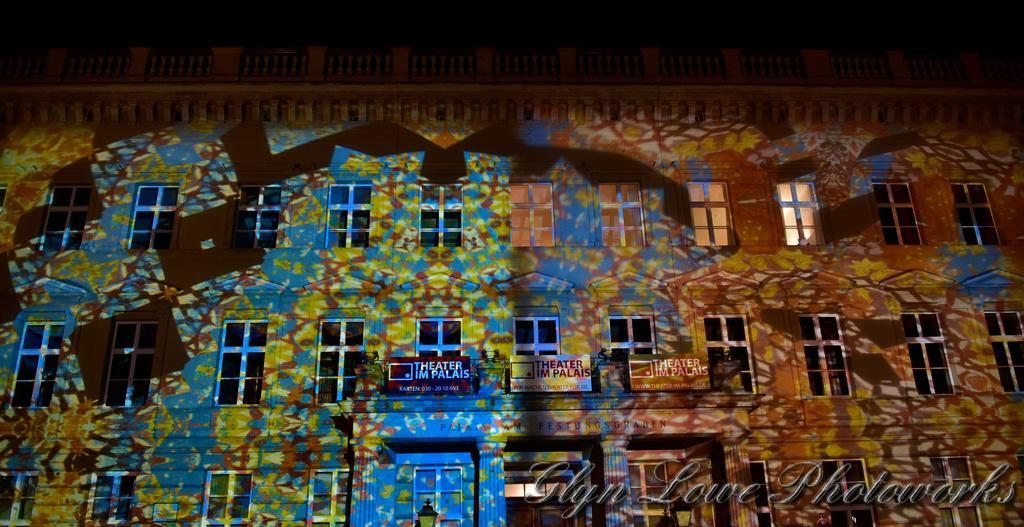What is present on the wall in the image? The wall has lights on it. Can you describe the lighting in the image? The lights on the wall provide illumination in the image. What part of the image appears to be darker? There is a dark part of the image. Is there any text or marking at the bottom right side of the image? Yes, there is a watermark at the bottom right side of the image. What type of bead is used to create the summer comfort in the image? There is no bead, summer, or comfort present in the image; it only features a wall with lights and a darker area. 